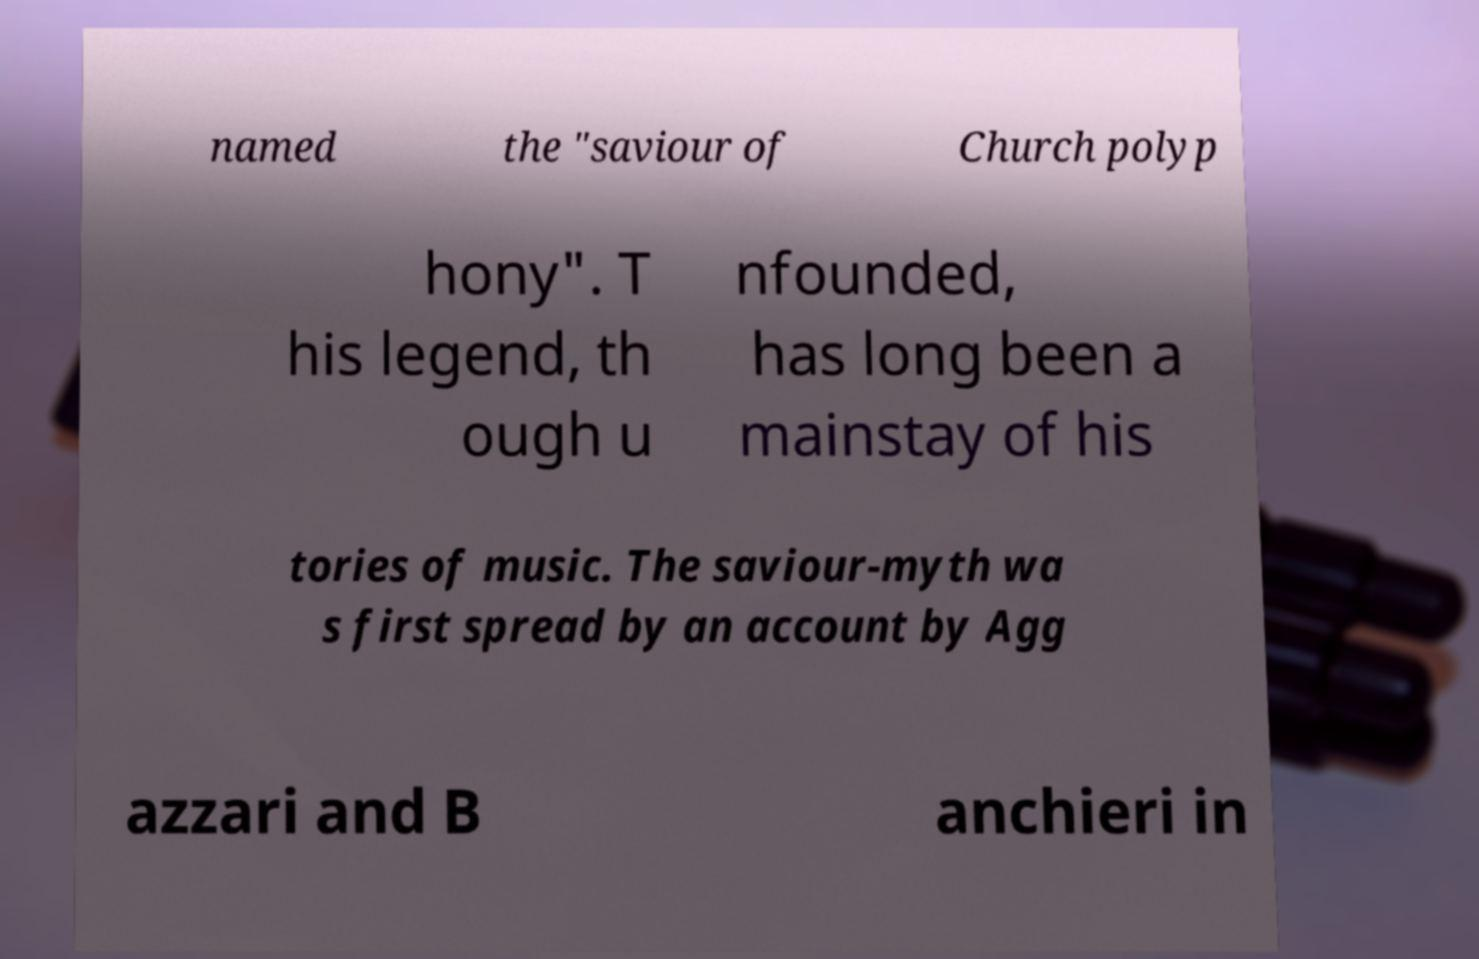Could you assist in decoding the text presented in this image and type it out clearly? named the "saviour of Church polyp hony". T his legend, th ough u nfounded, has long been a mainstay of his tories of music. The saviour-myth wa s first spread by an account by Agg azzari and B anchieri in 